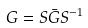<formula> <loc_0><loc_0><loc_500><loc_500>G = S \bar { G } S ^ { - 1 }</formula> 